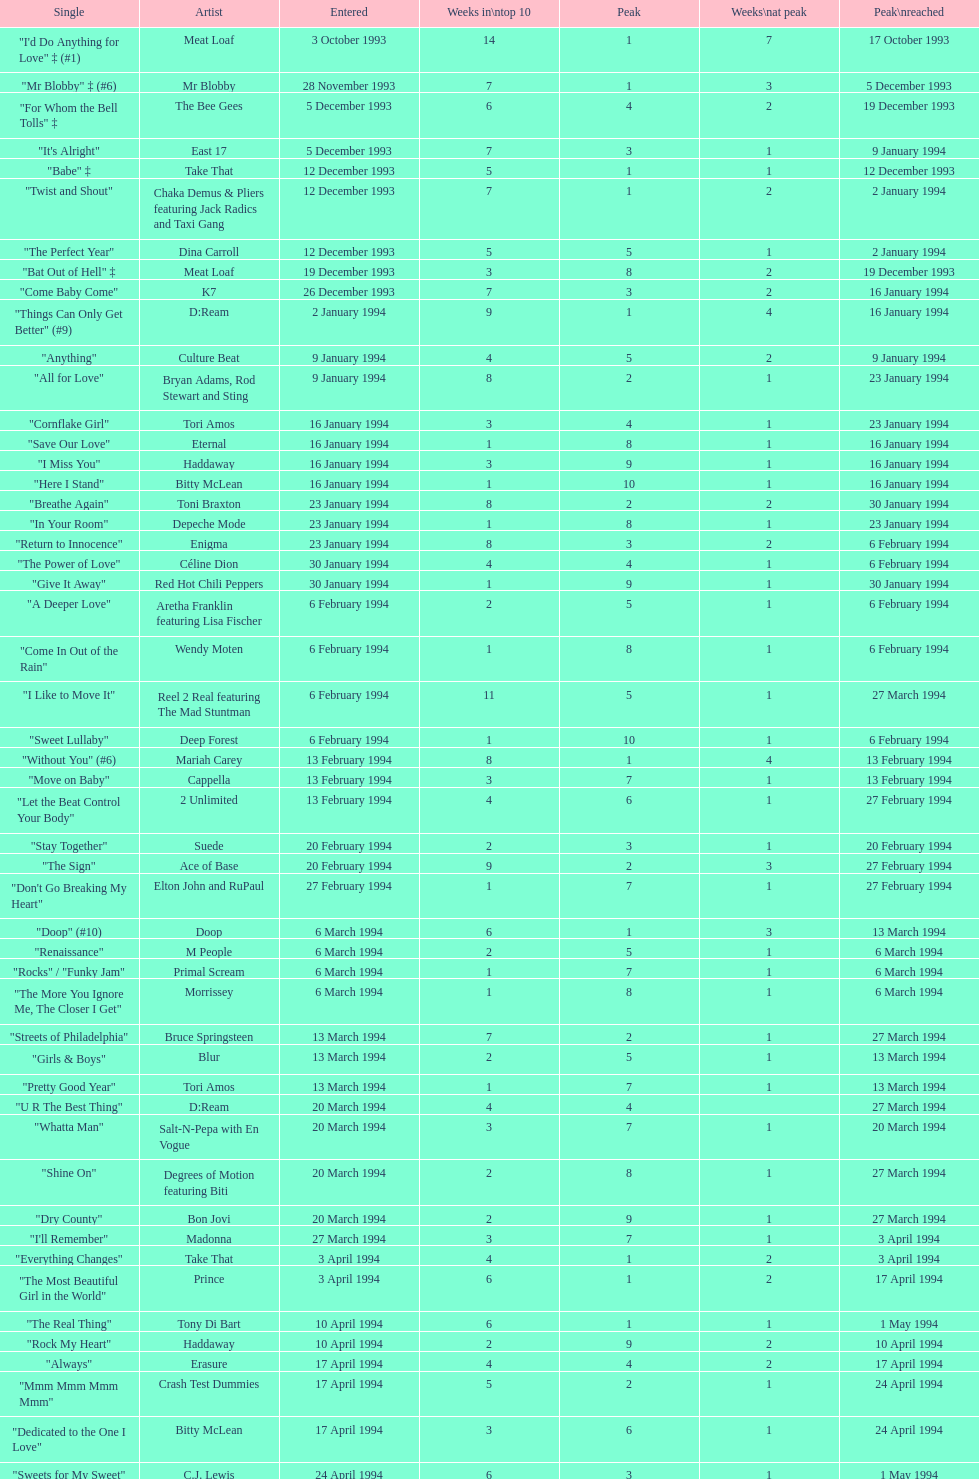Which single was the last one to be on the charts in 1993? "Come Baby Come". 